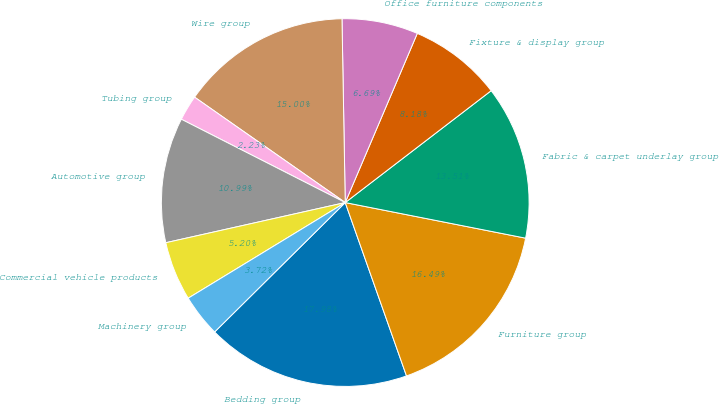Convert chart. <chart><loc_0><loc_0><loc_500><loc_500><pie_chart><fcel>Bedding group<fcel>Furniture group<fcel>Fabric & carpet underlay group<fcel>Fixture & display group<fcel>Office furniture components<fcel>Wire group<fcel>Tubing group<fcel>Automotive group<fcel>Commercial vehicle products<fcel>Machinery group<nl><fcel>17.98%<fcel>16.49%<fcel>13.51%<fcel>8.18%<fcel>6.69%<fcel>15.0%<fcel>2.23%<fcel>10.99%<fcel>5.2%<fcel>3.72%<nl></chart> 